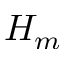Convert formula to latex. <formula><loc_0><loc_0><loc_500><loc_500>H _ { m }</formula> 